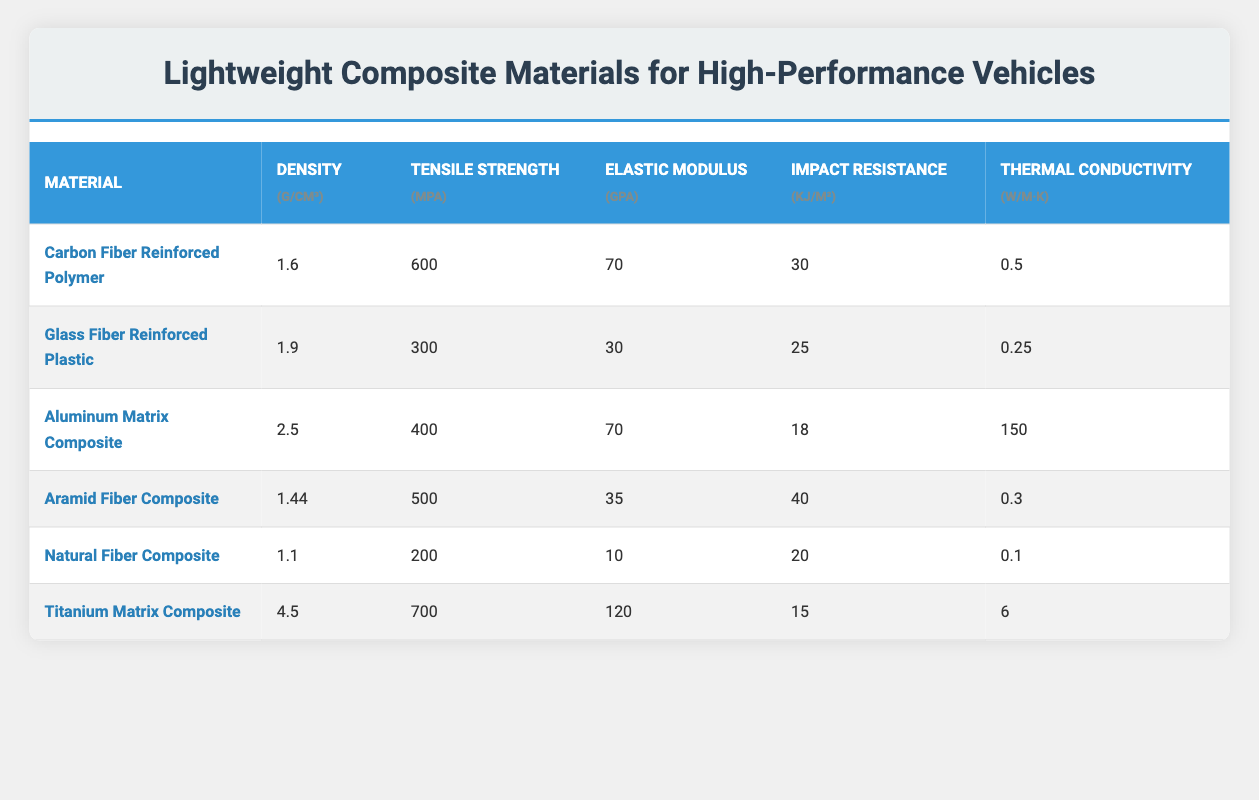What is the tensile strength of Carbon Fiber Reinforced Polymer? The tensile strength of Carbon Fiber Reinforced Polymer is listed in the second column, which states 600 MPa.
Answer: 600 MPa Which material has the highest density? By comparing the density values in the second column, the materials are listed as: 1.6 (Carbon Fiber Reinforced Polymer), 1.9 (Glass Fiber Reinforced Plastic), 2.5 (Aluminum Matrix Composite), 1.44 (Aramid Fiber Composite), 1.1 (Natural Fiber Composite), and 4.5 (Titanium Matrix Composite). The highest value is 4.5 for Titanium Matrix Composite.
Answer: Titanium Matrix Composite What is the average impact resistance of the materials listed? The impact resistance values are 30, 25, 18, 40, 20, and 15. First, add these values: 30 + 25 + 18 + 40 + 20 + 15 = 148. Next, divide by the number of materials (6) to calculate the average: 148 / 6 = 24.67, rounded to two decimal places gives approximately 24.67 kJ/m².
Answer: 24.67 kJ/m² Is the tensile strength of Aluminum Matrix Composite greater than that of Natural Fiber Composite? Checking the tensile strength values: Aluminum Matrix Composite has 400 MPa and Natural Fiber Composite has 200 MPa. Since 400 is greater than 200, the statement is true.
Answer: Yes Which material has the highest elastic modulus? The elastic modulus values to compare are: 70 (Carbon Fiber Reinforced Polymer), 30 (Glass Fiber Reinforced Plastic), 70 (Aluminum Matrix Composite), 35 (Aramid Fiber Composite), 10 (Natural Fiber Composite), and 120 (Titanium Matrix Composite). The highest value is 120 for Titanium Matrix Composite.
Answer: Titanium Matrix Composite Does any material have a thermal conductivity greater than 5 W/m·K? The thermal conductivity values are 0.5, 0.25, 150, 0.3, 0.1, and 6. The only value greater than 5 is 150 (Aluminum Matrix Composite). Therefore, there is a material that fits this criteria.
Answer: Yes What is the difference in tensile strength between Titanium Matrix Composite and Aramid Fiber Composite? The tensile strength of Titanium Matrix Composite is 700 MPa and for Aramid Fiber Composite, it is 500 MPa. To find the difference, subtract 500 from 700: 700 - 500 = 200.
Answer: 200 MPa What material has the lowest thermal conductivity? The thermal conductivity values to check are: 0.5, 0.25, 150, 0.3, 0.1, and 6. The lowest value is 0.1, which corresponds to Natural Fiber Composite.
Answer: Natural Fiber Composite Which material shows the best impact resistance? The impact resistance values are: 30 (Carbon Fiber Reinforced Polymer), 25 (Glass Fiber Reinforced Plastic), 18 (Aluminum Matrix Composite), 40 (Aramid Fiber Composite), 20 (Natural Fiber Composite), and 15 (Titanium Matrix Composite). The highest is 40 for Aramid Fiber Composite.
Answer: Aramid Fiber Composite 